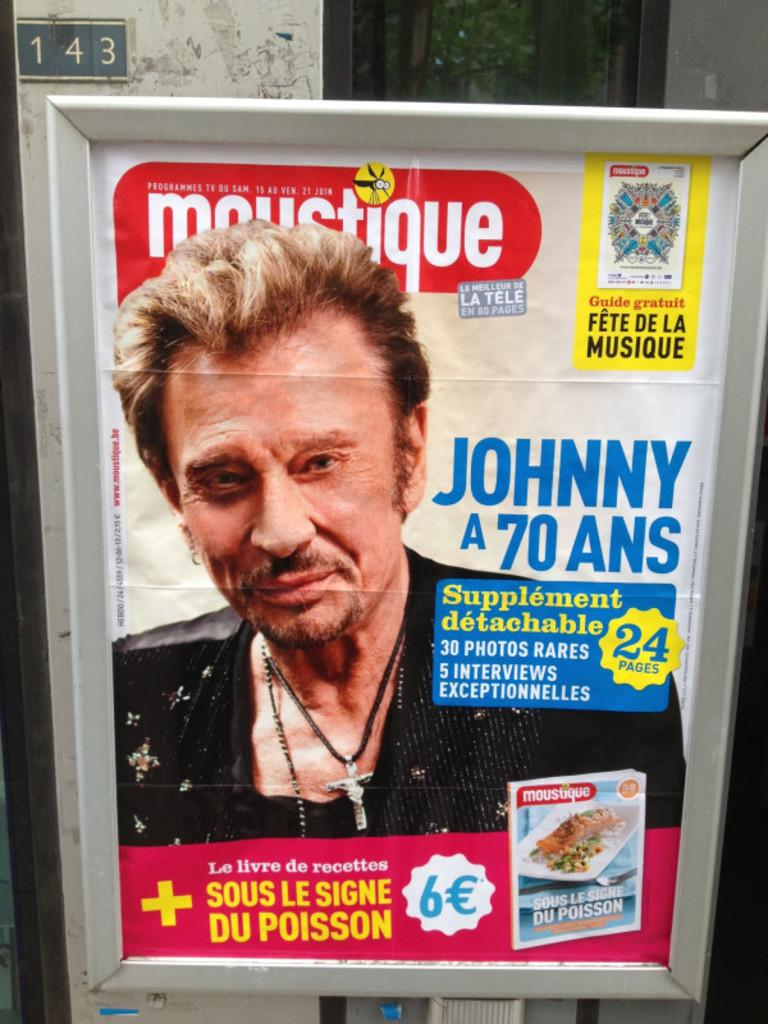What is featured on the poster in the image? The poster contains text and images. Can you describe the content of the poster? The poster contains text and images, but the specific content cannot be determined from the provided facts. What is visible in the background of the image? There is a background with numbers in the image. What type of structure is visible in the image? There is a wall visible in the image. What type of orange rhythm can be heard in the image? There is no audible sound or orange rhythm present in the image. 